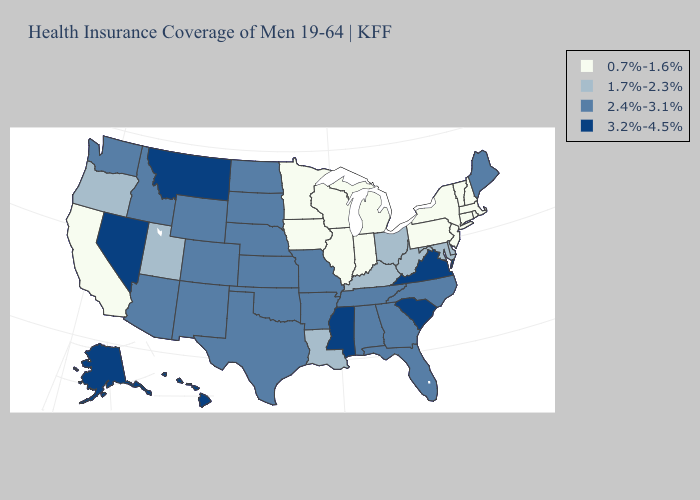What is the highest value in the USA?
Concise answer only. 3.2%-4.5%. Name the states that have a value in the range 3.2%-4.5%?
Write a very short answer. Alaska, Hawaii, Mississippi, Montana, Nevada, South Carolina, Virginia. Name the states that have a value in the range 2.4%-3.1%?
Short answer required. Alabama, Arizona, Arkansas, Colorado, Florida, Georgia, Idaho, Kansas, Maine, Missouri, Nebraska, New Mexico, North Carolina, North Dakota, Oklahoma, South Dakota, Tennessee, Texas, Washington, Wyoming. Name the states that have a value in the range 3.2%-4.5%?
Short answer required. Alaska, Hawaii, Mississippi, Montana, Nevada, South Carolina, Virginia. Does Kentucky have a higher value than Iowa?
Write a very short answer. Yes. What is the value of Illinois?
Give a very brief answer. 0.7%-1.6%. Name the states that have a value in the range 2.4%-3.1%?
Quick response, please. Alabama, Arizona, Arkansas, Colorado, Florida, Georgia, Idaho, Kansas, Maine, Missouri, Nebraska, New Mexico, North Carolina, North Dakota, Oklahoma, South Dakota, Tennessee, Texas, Washington, Wyoming. Among the states that border Maryland , does Virginia have the highest value?
Answer briefly. Yes. Name the states that have a value in the range 2.4%-3.1%?
Keep it brief. Alabama, Arizona, Arkansas, Colorado, Florida, Georgia, Idaho, Kansas, Maine, Missouri, Nebraska, New Mexico, North Carolina, North Dakota, Oklahoma, South Dakota, Tennessee, Texas, Washington, Wyoming. Name the states that have a value in the range 2.4%-3.1%?
Write a very short answer. Alabama, Arizona, Arkansas, Colorado, Florida, Georgia, Idaho, Kansas, Maine, Missouri, Nebraska, New Mexico, North Carolina, North Dakota, Oklahoma, South Dakota, Tennessee, Texas, Washington, Wyoming. Which states have the lowest value in the USA?
Concise answer only. California, Connecticut, Illinois, Indiana, Iowa, Massachusetts, Michigan, Minnesota, New Hampshire, New Jersey, New York, Pennsylvania, Rhode Island, Vermont, Wisconsin. Name the states that have a value in the range 0.7%-1.6%?
Write a very short answer. California, Connecticut, Illinois, Indiana, Iowa, Massachusetts, Michigan, Minnesota, New Hampshire, New Jersey, New York, Pennsylvania, Rhode Island, Vermont, Wisconsin. Among the states that border Wisconsin , which have the highest value?
Quick response, please. Illinois, Iowa, Michigan, Minnesota. Does Iowa have the highest value in the MidWest?
Give a very brief answer. No. What is the lowest value in the USA?
Answer briefly. 0.7%-1.6%. 